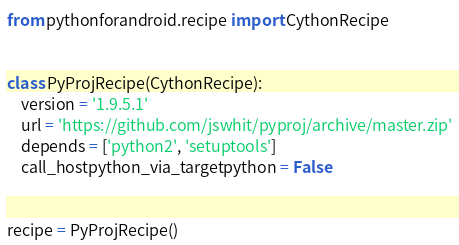Convert code to text. <code><loc_0><loc_0><loc_500><loc_500><_Python_>from pythonforandroid.recipe import CythonRecipe


class PyProjRecipe(CythonRecipe):
    version = '1.9.5.1'
    url = 'https://github.com/jswhit/pyproj/archive/master.zip'
    depends = ['python2', 'setuptools']
    call_hostpython_via_targetpython = False


recipe = PyProjRecipe()
</code> 